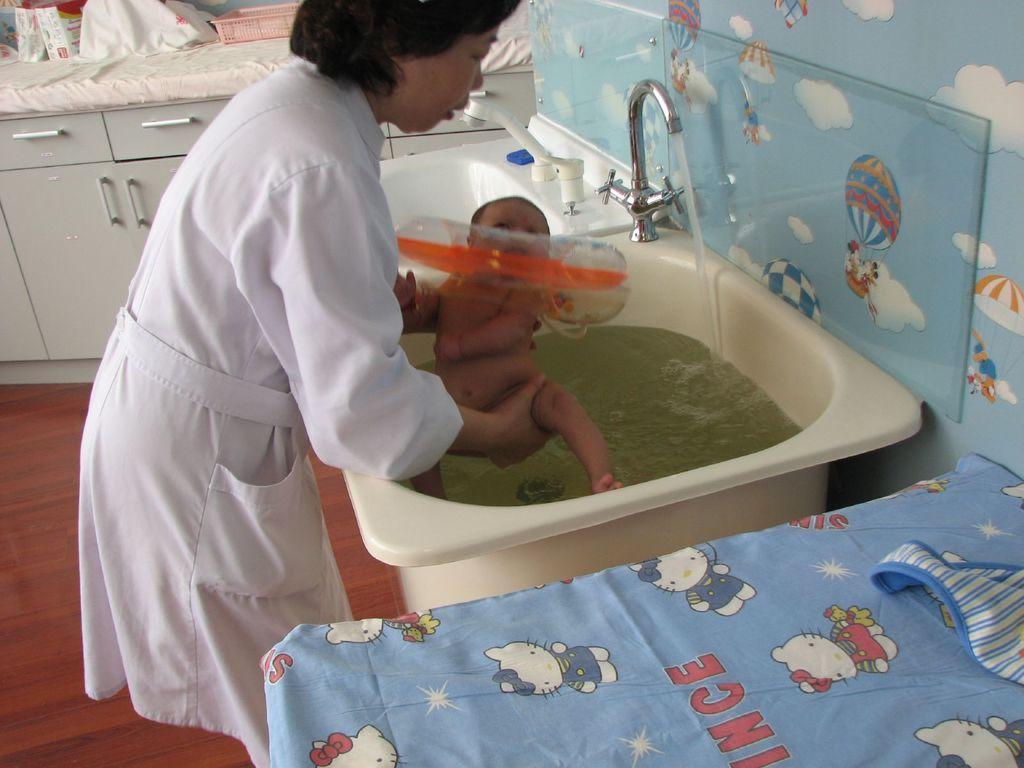In one or two sentences, can you explain what this image depicts? In this picture I can observe a woman holding a baby in front of a sink. I can observe tap on the sink. There is some water in the sink. In the background I can observe cupboards. 